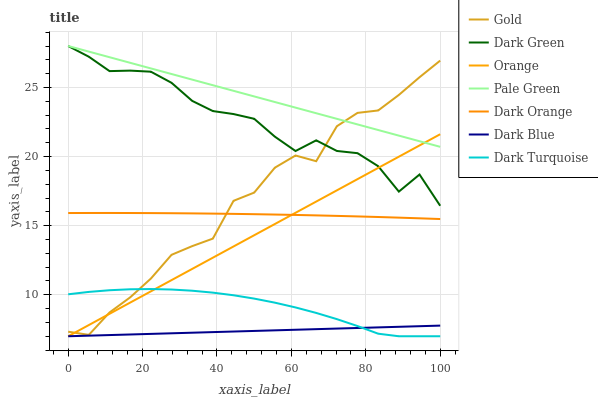Does Dark Blue have the minimum area under the curve?
Answer yes or no. Yes. Does Pale Green have the maximum area under the curve?
Answer yes or no. Yes. Does Gold have the minimum area under the curve?
Answer yes or no. No. Does Gold have the maximum area under the curve?
Answer yes or no. No. Is Orange the smoothest?
Answer yes or no. Yes. Is Gold the roughest?
Answer yes or no. Yes. Is Dark Turquoise the smoothest?
Answer yes or no. No. Is Dark Turquoise the roughest?
Answer yes or no. No. Does Dark Turquoise have the lowest value?
Answer yes or no. Yes. Does Gold have the lowest value?
Answer yes or no. No. Does Dark Green have the highest value?
Answer yes or no. Yes. Does Gold have the highest value?
Answer yes or no. No. Is Dark Turquoise less than Dark Orange?
Answer yes or no. Yes. Is Dark Green greater than Dark Orange?
Answer yes or no. Yes. Does Pale Green intersect Dark Green?
Answer yes or no. Yes. Is Pale Green less than Dark Green?
Answer yes or no. No. Is Pale Green greater than Dark Green?
Answer yes or no. No. Does Dark Turquoise intersect Dark Orange?
Answer yes or no. No. 